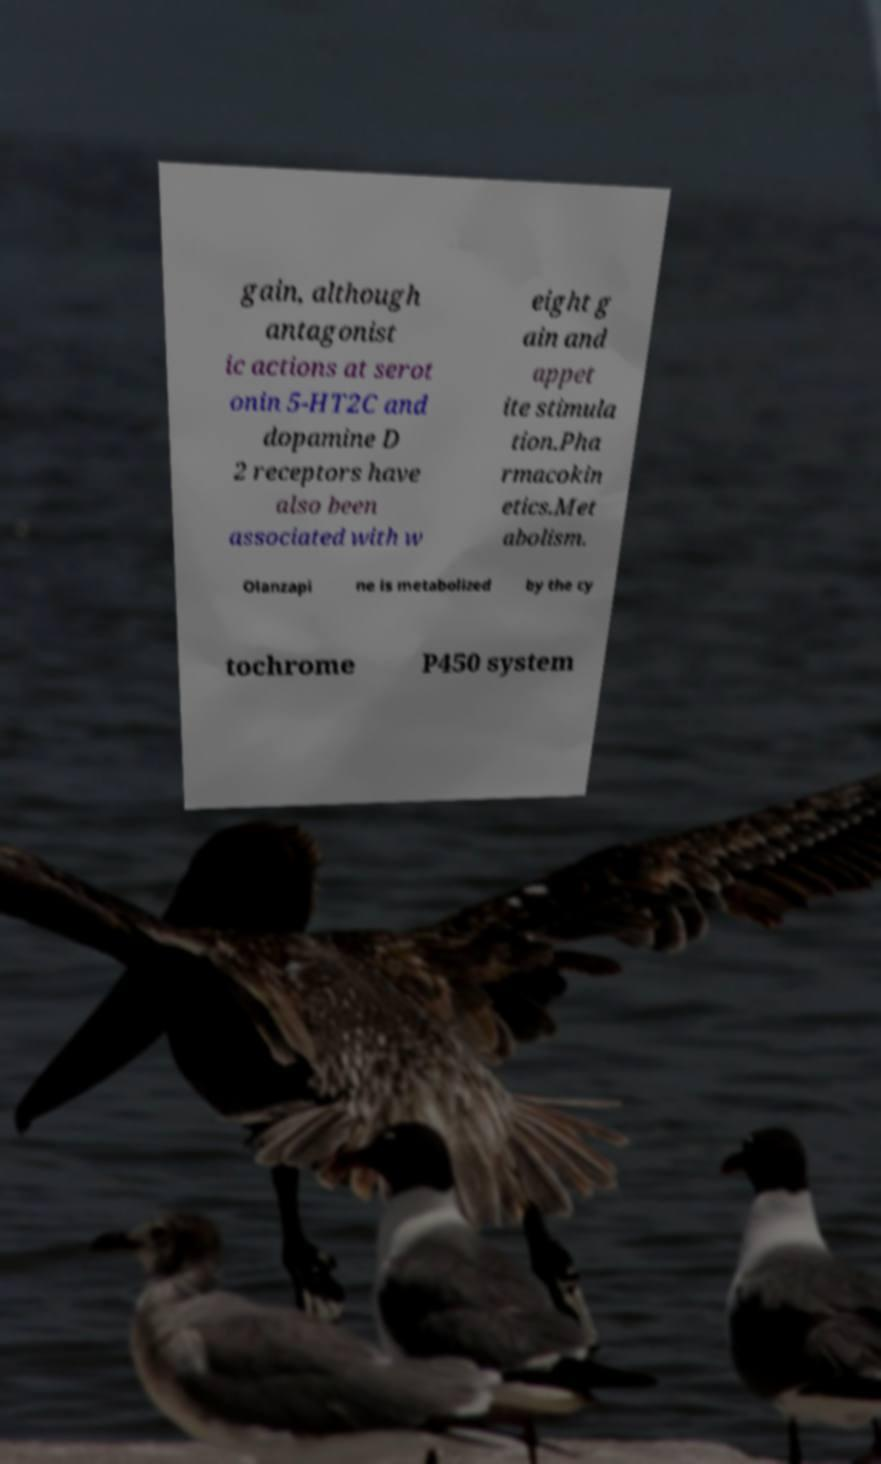Please identify and transcribe the text found in this image. gain, although antagonist ic actions at serot onin 5-HT2C and dopamine D 2 receptors have also been associated with w eight g ain and appet ite stimula tion.Pha rmacokin etics.Met abolism. Olanzapi ne is metabolized by the cy tochrome P450 system 